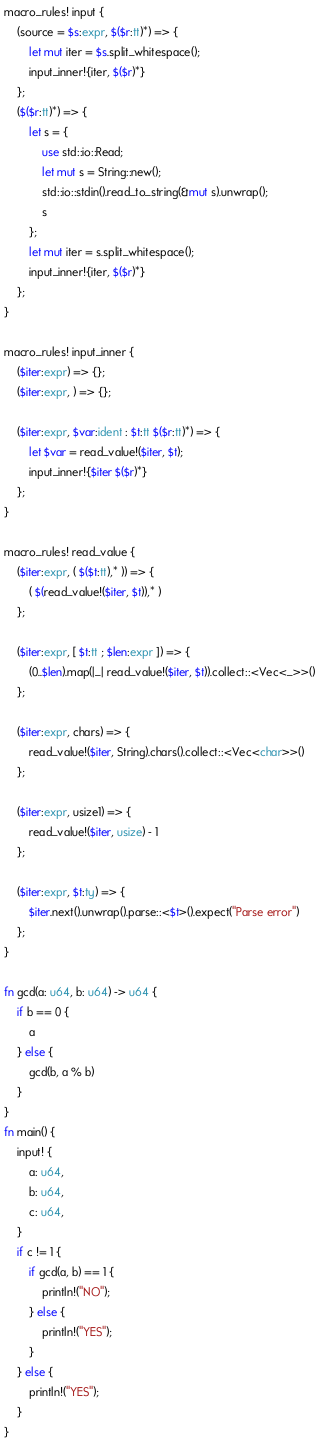Convert code to text. <code><loc_0><loc_0><loc_500><loc_500><_Rust_>macro_rules! input {
    (source = $s:expr, $($r:tt)*) => {
        let mut iter = $s.split_whitespace();
        input_inner!{iter, $($r)*}
    };
    ($($r:tt)*) => {
        let s = {
            use std::io::Read;
            let mut s = String::new();
            std::io::stdin().read_to_string(&mut s).unwrap();
            s
        };
        let mut iter = s.split_whitespace();
        input_inner!{iter, $($r)*}
    };
}

macro_rules! input_inner {
    ($iter:expr) => {};
    ($iter:expr, ) => {};

    ($iter:expr, $var:ident : $t:tt $($r:tt)*) => {
        let $var = read_value!($iter, $t);
        input_inner!{$iter $($r)*}
    };
}

macro_rules! read_value {
    ($iter:expr, ( $($t:tt),* )) => {
        ( $(read_value!($iter, $t)),* )
    };

    ($iter:expr, [ $t:tt ; $len:expr ]) => {
        (0..$len).map(|_| read_value!($iter, $t)).collect::<Vec<_>>()
    };

    ($iter:expr, chars) => {
        read_value!($iter, String).chars().collect::<Vec<char>>()
    };

    ($iter:expr, usize1) => {
        read_value!($iter, usize) - 1
    };

    ($iter:expr, $t:ty) => {
        $iter.next().unwrap().parse::<$t>().expect("Parse error")
    };
}

fn gcd(a: u64, b: u64) -> u64 {
    if b == 0 {
        a
    } else {
        gcd(b, a % b)
    }
}
fn main() {
    input! {
        a: u64,
        b: u64,
        c: u64,
    }
    if c != 1 {
        if gcd(a, b) == 1 {
            println!("NO");
        } else {
            println!("YES");
        }
    } else {
        println!("YES");
    }
}</code> 